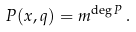Convert formula to latex. <formula><loc_0><loc_0><loc_500><loc_500>P ( x , q ) = m ^ { \deg P } \, .</formula> 